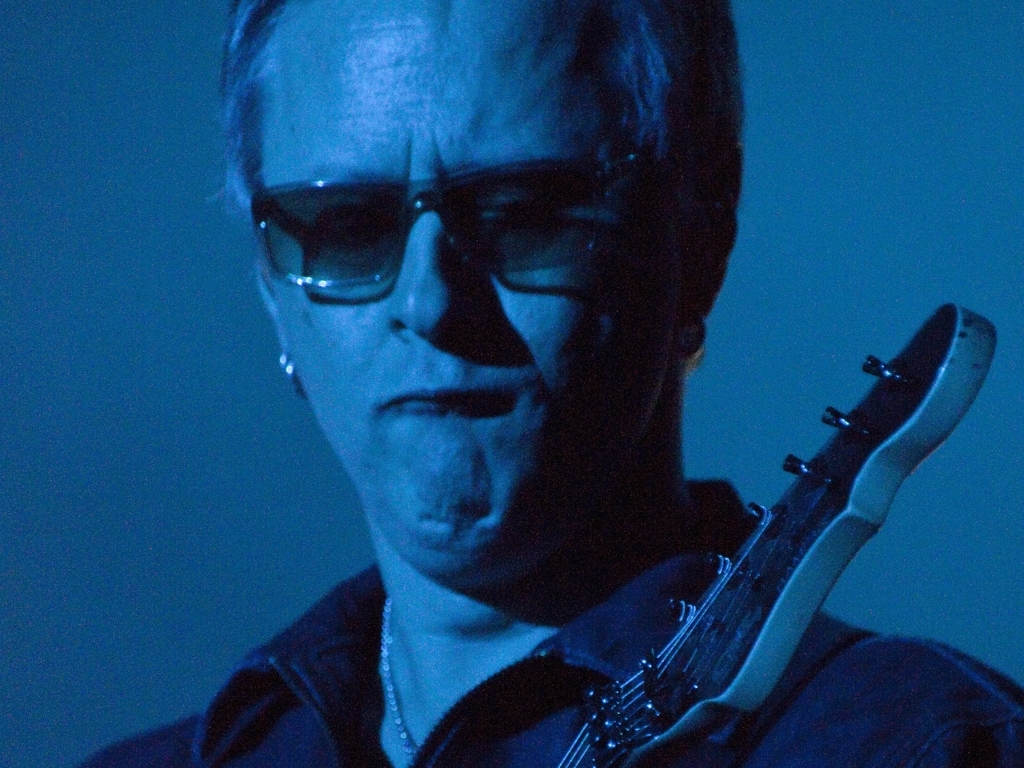Why is the overall image considered poor in quality?
A. The image surpasses the expectations with its quality.
B. The image is relatively blurry and has various issues in texture, expression, and color selection.
C. The image has exceptional texture, expression, and color.
D. The image is sharp and visually appealing with perfect details.
Answer with the option's letter from the given choices directly.
 B. 